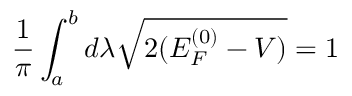<formula> <loc_0><loc_0><loc_500><loc_500>\frac { 1 } { \pi } \int _ { a } ^ { b } d \lambda \sqrt { 2 ( E _ { F } ^ { ( 0 ) } - V ) } = 1</formula> 